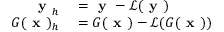Convert formula to latex. <formula><loc_0><loc_0><loc_500><loc_500>\begin{array} { r l } { y _ { h } } & = y - \ m a t h s c r { L } ( y ) } \\ { G ( x ) _ { h } } & = G ( x ) - \ m a t h s c r { L } ( G ( x ) ) } \end{array}</formula> 